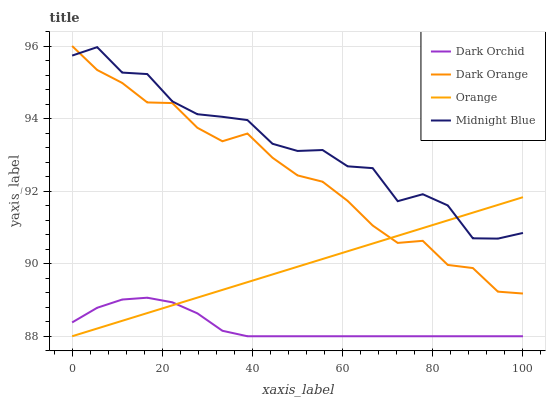Does Dark Orchid have the minimum area under the curve?
Answer yes or no. Yes. Does Midnight Blue have the maximum area under the curve?
Answer yes or no. Yes. Does Dark Orange have the minimum area under the curve?
Answer yes or no. No. Does Dark Orange have the maximum area under the curve?
Answer yes or no. No. Is Orange the smoothest?
Answer yes or no. Yes. Is Midnight Blue the roughest?
Answer yes or no. Yes. Is Dark Orange the smoothest?
Answer yes or no. No. Is Dark Orange the roughest?
Answer yes or no. No. Does Dark Orange have the lowest value?
Answer yes or no. No. Does Midnight Blue have the highest value?
Answer yes or no. No. Is Dark Orchid less than Dark Orange?
Answer yes or no. Yes. Is Midnight Blue greater than Dark Orchid?
Answer yes or no. Yes. Does Dark Orchid intersect Dark Orange?
Answer yes or no. No. 